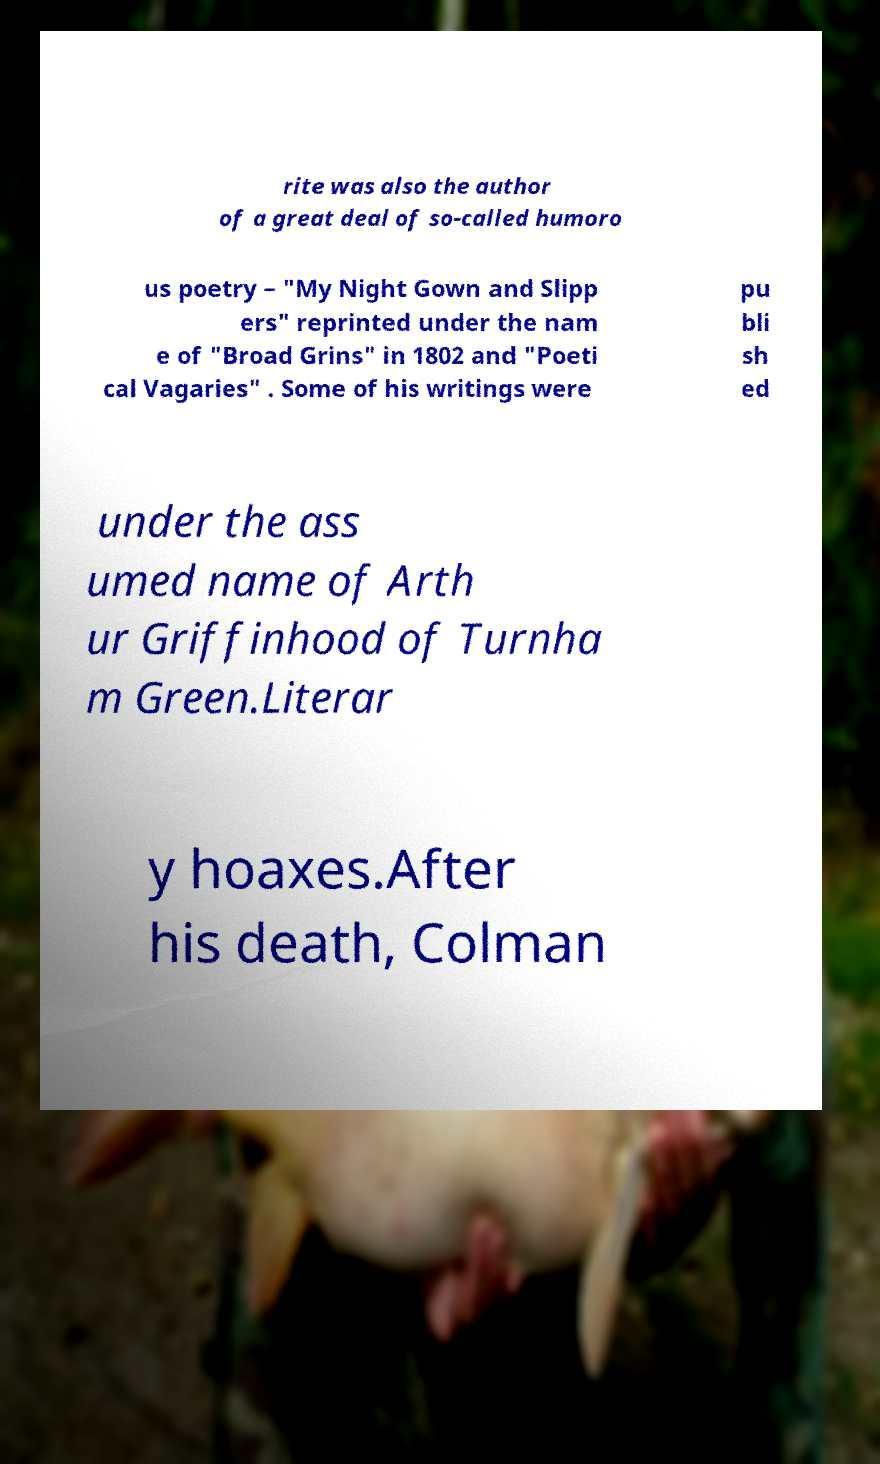For documentation purposes, I need the text within this image transcribed. Could you provide that? rite was also the author of a great deal of so-called humoro us poetry – "My Night Gown and Slipp ers" reprinted under the nam e of "Broad Grins" in 1802 and "Poeti cal Vagaries" . Some of his writings were pu bli sh ed under the ass umed name of Arth ur Griffinhood of Turnha m Green.Literar y hoaxes.After his death, Colman 